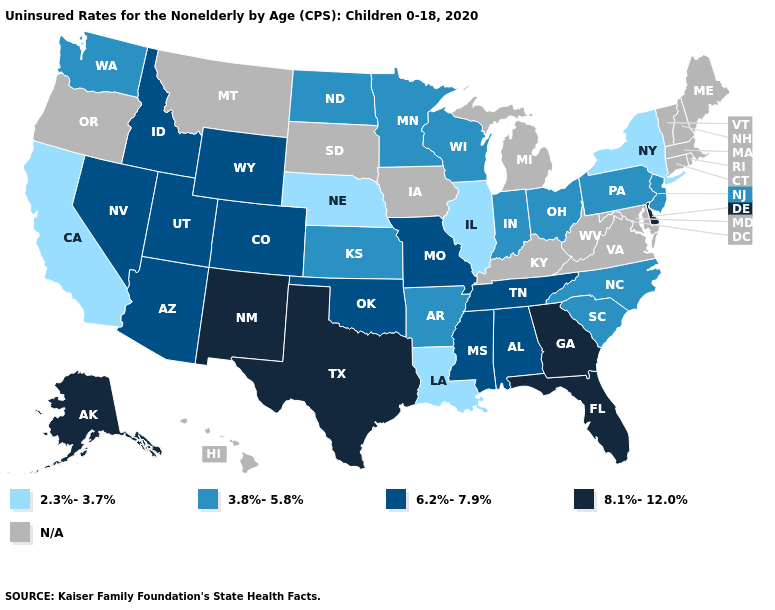How many symbols are there in the legend?
Write a very short answer. 5. What is the lowest value in states that border Montana?
Write a very short answer. 3.8%-5.8%. What is the value of South Carolina?
Give a very brief answer. 3.8%-5.8%. Which states have the lowest value in the USA?
Be succinct. California, Illinois, Louisiana, Nebraska, New York. Does Missouri have the lowest value in the USA?
Short answer required. No. Does Illinois have the lowest value in the USA?
Quick response, please. Yes. Which states have the highest value in the USA?
Concise answer only. Alaska, Delaware, Florida, Georgia, New Mexico, Texas. Name the states that have a value in the range N/A?
Give a very brief answer. Connecticut, Hawaii, Iowa, Kentucky, Maine, Maryland, Massachusetts, Michigan, Montana, New Hampshire, Oregon, Rhode Island, South Dakota, Vermont, Virginia, West Virginia. Among the states that border Maryland , does Delaware have the lowest value?
Answer briefly. No. Which states have the lowest value in the USA?
Quick response, please. California, Illinois, Louisiana, Nebraska, New York. Which states have the lowest value in the USA?
Short answer required. California, Illinois, Louisiana, Nebraska, New York. Name the states that have a value in the range 6.2%-7.9%?
Write a very short answer. Alabama, Arizona, Colorado, Idaho, Mississippi, Missouri, Nevada, Oklahoma, Tennessee, Utah, Wyoming. Name the states that have a value in the range 2.3%-3.7%?
Write a very short answer. California, Illinois, Louisiana, Nebraska, New York. What is the highest value in the USA?
Be succinct. 8.1%-12.0%. Which states have the lowest value in the USA?
Be succinct. California, Illinois, Louisiana, Nebraska, New York. 